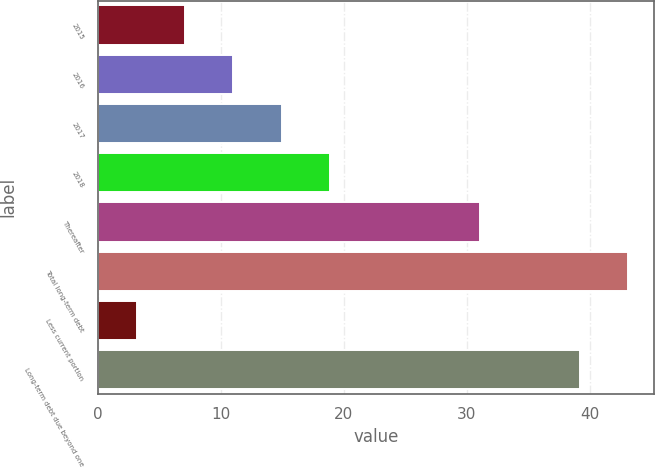Convert chart. <chart><loc_0><loc_0><loc_500><loc_500><bar_chart><fcel>2015<fcel>2016<fcel>2017<fcel>2018<fcel>Thereafter<fcel>Total long-term debt<fcel>Less current portion<fcel>Long-term debt due beyond one<nl><fcel>7.12<fcel>11.04<fcel>14.96<fcel>18.88<fcel>31.1<fcel>43.12<fcel>3.2<fcel>39.2<nl></chart> 